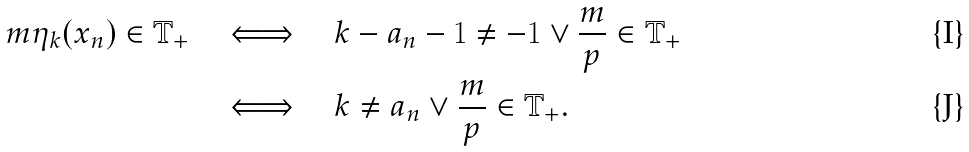<formula> <loc_0><loc_0><loc_500><loc_500>m \eta _ { k } ( x _ { n } ) \in \mathbb { T } _ { + } \quad & \Longleftrightarrow \quad k - a _ { n } - 1 \neq - 1 \vee \frac { m } { p } \in \mathbb { T } _ { + } \\ & \Longleftrightarrow \quad k \neq a _ { n } \vee \frac { m } { p } \in \mathbb { T } _ { + } .</formula> 